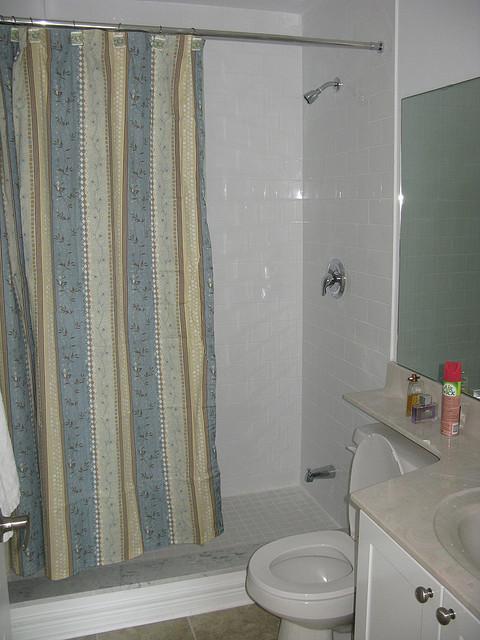What pattern is on the shower curtain?
Answer briefly. Stripes. Is the shower curtain open?
Concise answer only. Yes. What type of print is on the shower curtain?
Answer briefly. Stripes. Is the toilet seat up or down?
Concise answer only. Down. How many bottles are in the shower?
Keep it brief. 0. What model toilet is this?
Give a very brief answer. Unknown. Is the toilet seat up?
Give a very brief answer. Yes. Is there a spray in this room?
Keep it brief. Yes. What color is the shower curtain?
Be succinct. Blue. Is the toilet seat down?
Keep it brief. No. Is the shower curtain solid or striped?
Quick response, please. Striped. Does the bathroom belong to an adult or a child?
Concise answer only. Adult. Is there soap on the sink?
Answer briefly. No. 